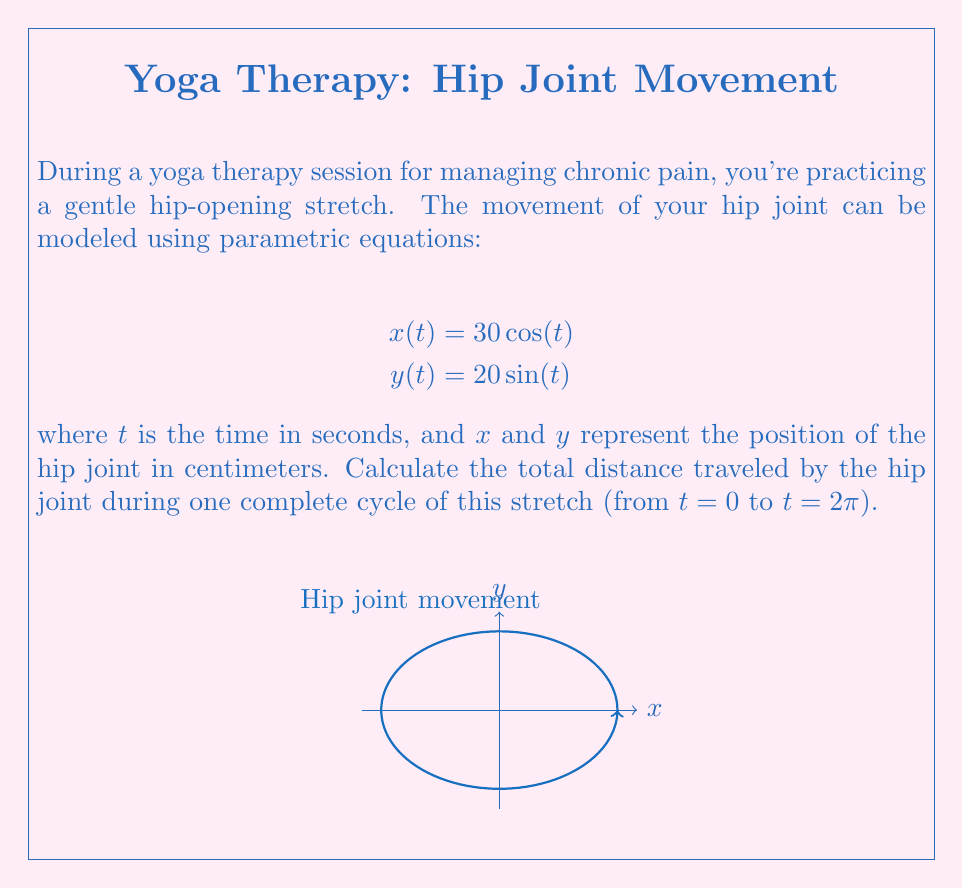Show me your answer to this math problem. To solve this problem, we'll follow these steps:

1) The parametric equations describe an ellipse. We need to find the circumference of this ellipse.

2) For an ellipse, there's no simple formula for the exact circumference. However, we can use Ramanujan's approximation:

   $$C \approx \pi(a+b)\left(1 + \frac{3h}{10 + \sqrt{4-3h}}\right)$$

   where $a$ and $b$ are the semi-major and semi-minor axes, and $h = \frac{(a-b)^2}{(a+b)^2}$

3) From our equations, we can see that $a = 30$ and $b = 20$.

4) Let's calculate $h$:
   $$h = \frac{(30-20)^2}{(30+20)^2} = \frac{100}{2500} = 0.04$$

5) Now we can plug these values into Ramanujan's formula:

   $$C \approx \pi(30+20)\left(1 + \frac{3(0.04)}{10 + \sqrt{4-3(0.04)}}\right)$$

6) Simplifying:
   $$C \approx 50\pi\left(1 + \frac{0.12}{10 + \sqrt{3.88}}\right)$$
   $$C \approx 50\pi(1.0059)$$
   $$C \approx 158.35 \text{ cm}$$

Therefore, the total distance traveled by the hip joint during one complete cycle of this stretch is approximately 158.35 cm.
Answer: $158.35 \text{ cm}$ 